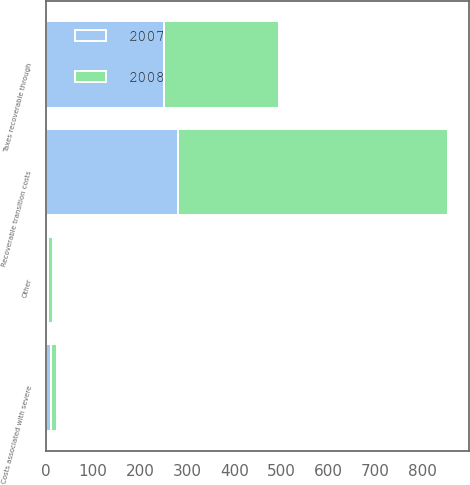Convert chart to OTSL. <chart><loc_0><loc_0><loc_500><loc_500><stacked_bar_chart><ecel><fcel>Recoverable transition costs<fcel>Taxes recoverable through<fcel>Costs associated with severe<fcel>Other<nl><fcel>2007<fcel>281<fcel>250<fcel>11<fcel>3<nl><fcel>2008<fcel>574<fcel>245<fcel>12<fcel>12<nl></chart> 